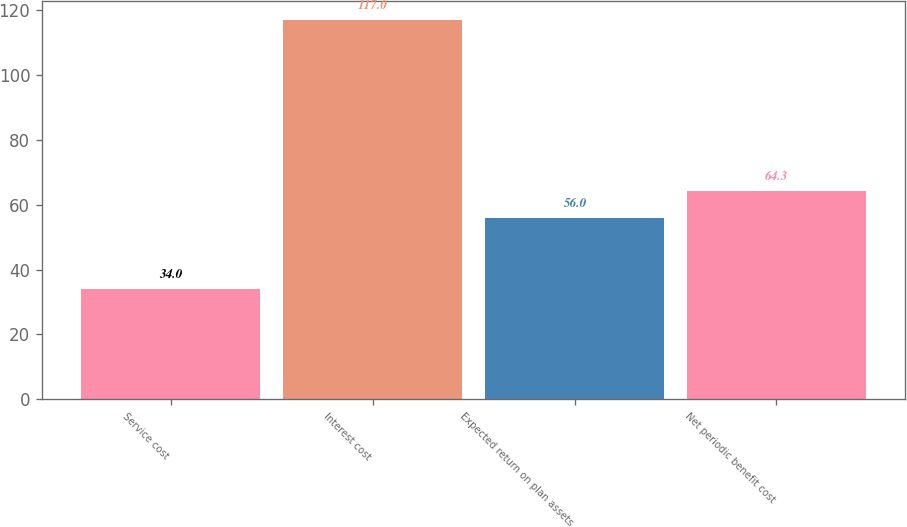Convert chart to OTSL. <chart><loc_0><loc_0><loc_500><loc_500><bar_chart><fcel>Service cost<fcel>Interest cost<fcel>Expected return on plan assets<fcel>Net periodic benefit cost<nl><fcel>34<fcel>117<fcel>56<fcel>64.3<nl></chart> 